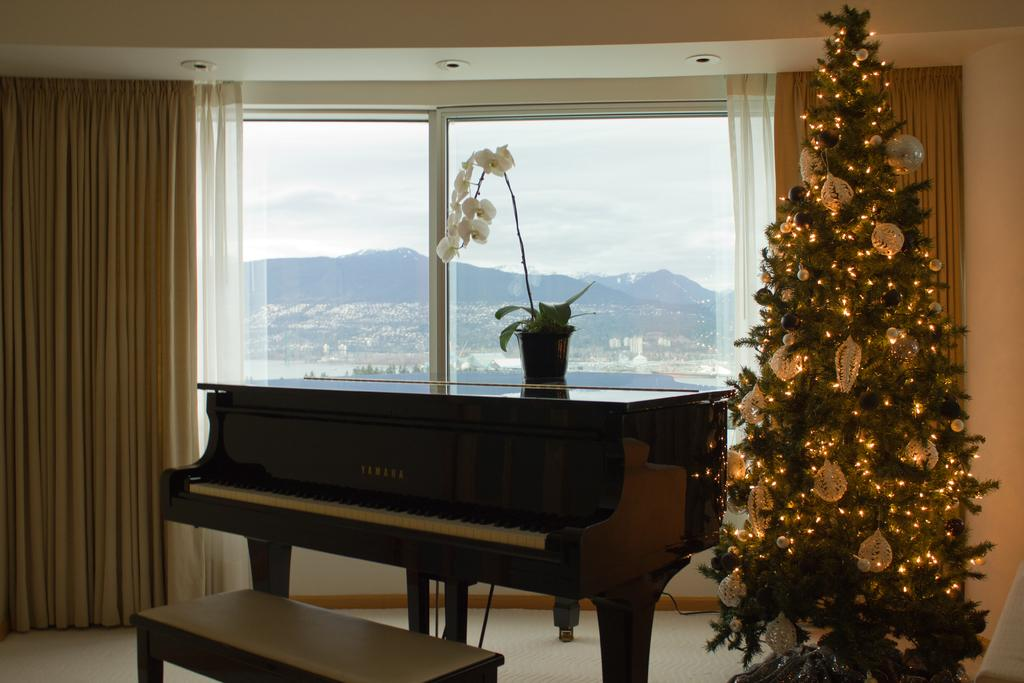What type of space is depicted in the image? There is a room in the image. What type of window treatment is present in the room? There is a curtain in the room. What type of furniture is present in the room? There is a table in the room. What type of decorative item is present in the room? There is a flower vase in the room. What type of seating is present in the room? There is a bench in the room. What can be seen in the background of the image? There is a mountain, sky, and trees visible in the background of the image. What type of nation is represented by the committee in the image? There is no committee or nation present in the image; it depicts a room with various items and a background featuring a mountain, sky, and trees. 